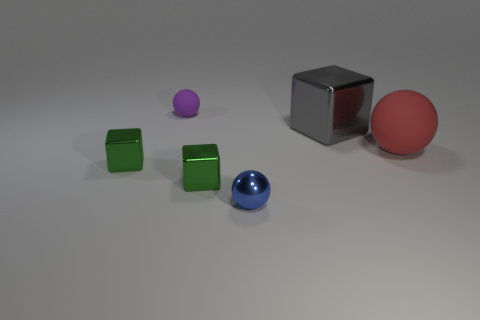Add 1 big red things. How many objects exist? 7 Subtract 1 red balls. How many objects are left? 5 Subtract all gray metallic blocks. Subtract all blue things. How many objects are left? 4 Add 1 blocks. How many blocks are left? 4 Add 1 tiny green shiny objects. How many tiny green shiny objects exist? 3 